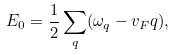<formula> <loc_0><loc_0><loc_500><loc_500>E _ { 0 } = \frac { 1 } { 2 } \sum _ { q } ( \omega _ { q } - v _ { F } q ) ,</formula> 